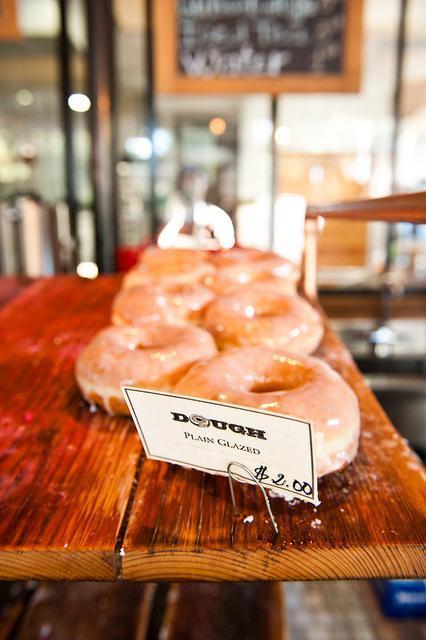How many donuts?
Give a very brief answer. 8. How many donuts are there?
Give a very brief answer. 5. 